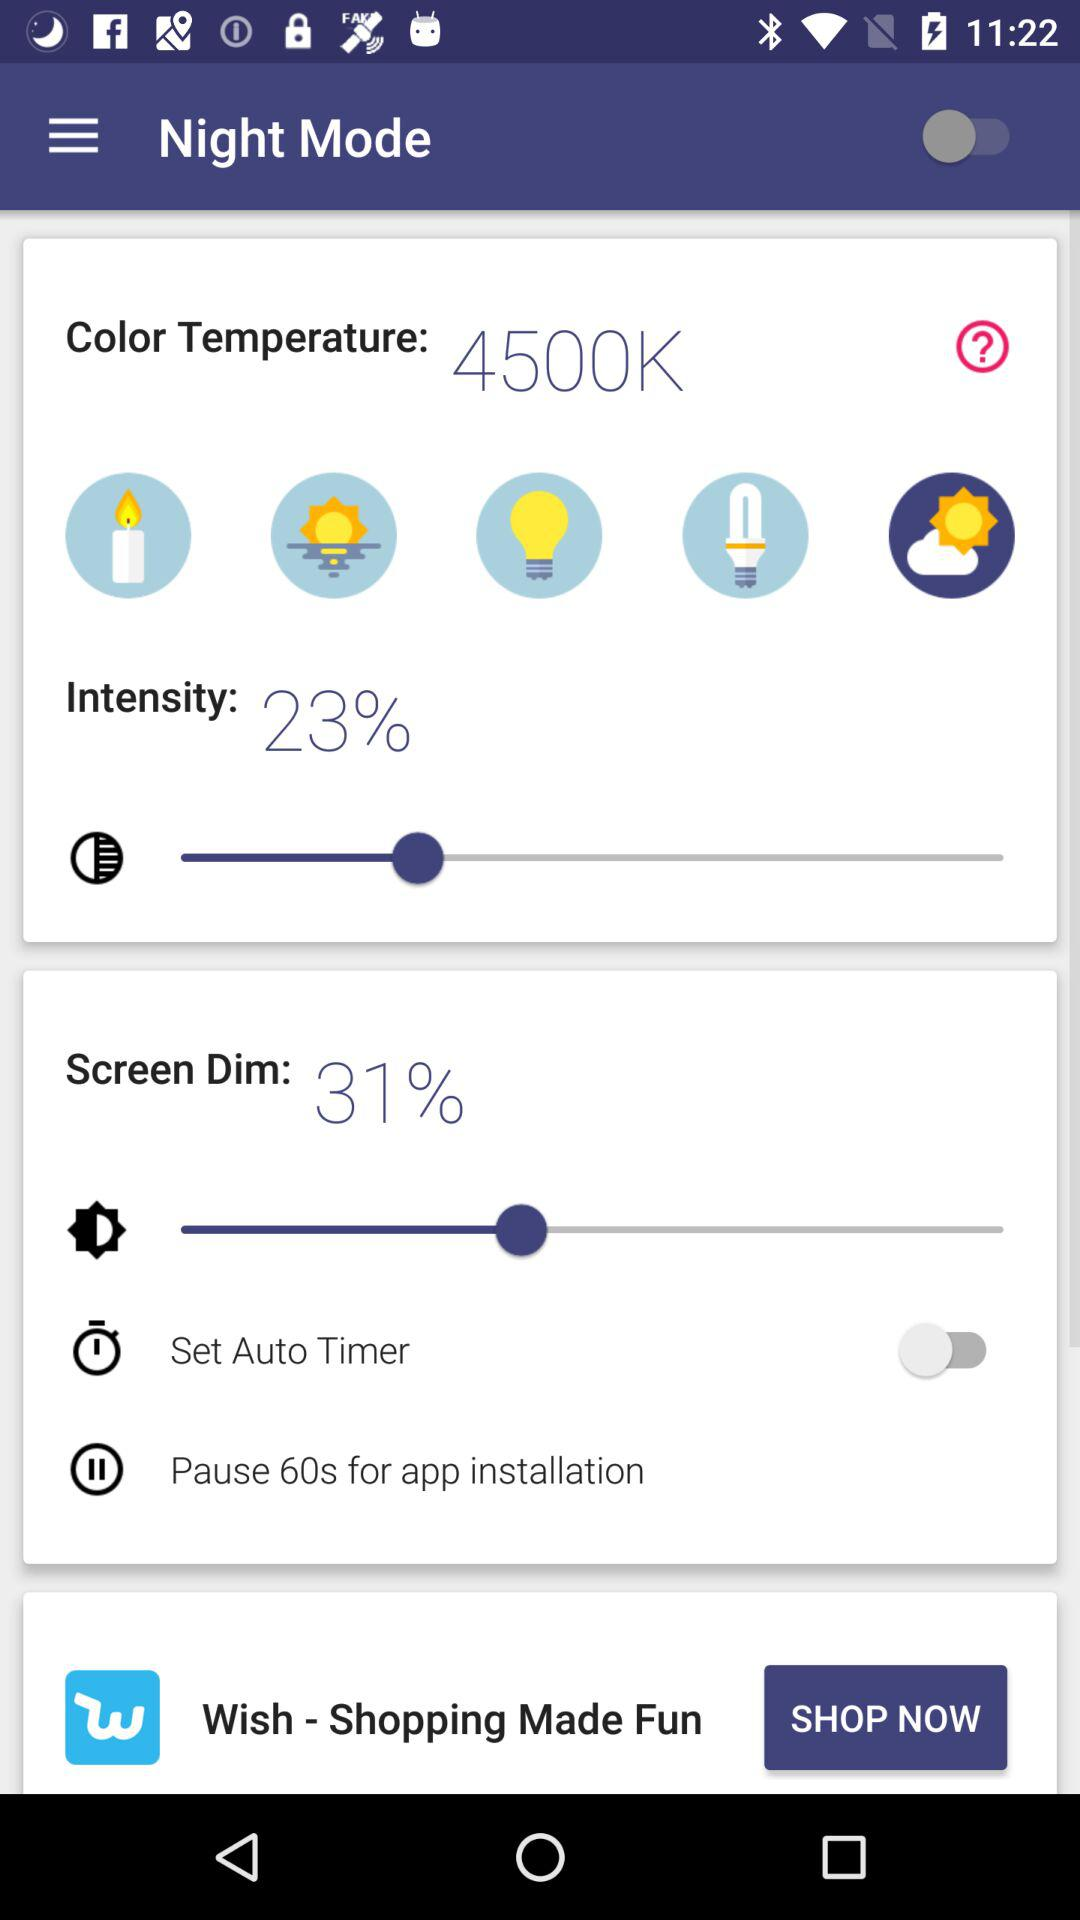What is the status of "Night Mode"? The status is "off". 